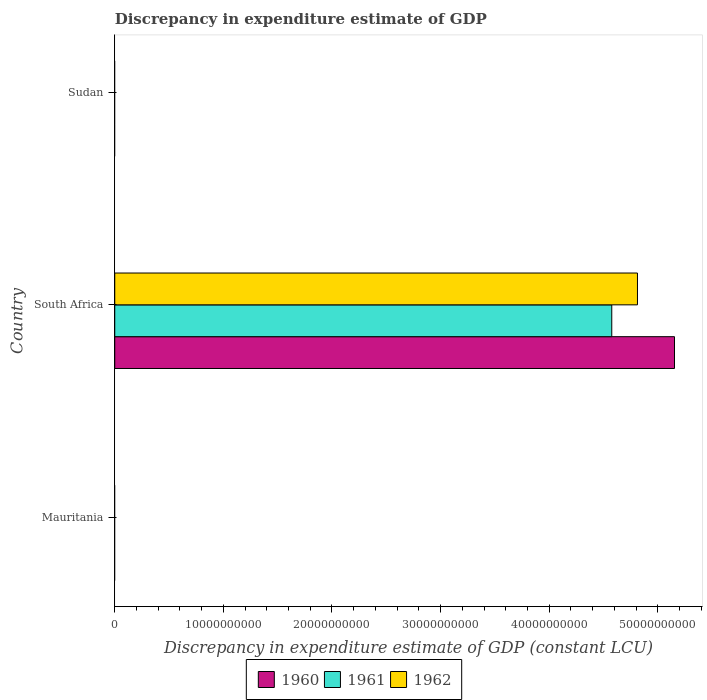How many different coloured bars are there?
Provide a succinct answer. 3. Are the number of bars on each tick of the Y-axis equal?
Your answer should be very brief. No. How many bars are there on the 3rd tick from the top?
Offer a very short reply. 0. How many bars are there on the 3rd tick from the bottom?
Ensure brevity in your answer.  0. What is the label of the 1st group of bars from the top?
Offer a terse response. Sudan. What is the discrepancy in expenditure estimate of GDP in 1960 in South Africa?
Provide a succinct answer. 5.15e+1. Across all countries, what is the maximum discrepancy in expenditure estimate of GDP in 1961?
Your answer should be very brief. 4.58e+1. In which country was the discrepancy in expenditure estimate of GDP in 1961 maximum?
Give a very brief answer. South Africa. What is the total discrepancy in expenditure estimate of GDP in 1961 in the graph?
Your response must be concise. 4.58e+1. What is the difference between the discrepancy in expenditure estimate of GDP in 1961 in Sudan and the discrepancy in expenditure estimate of GDP in 1962 in South Africa?
Make the answer very short. -4.81e+1. What is the average discrepancy in expenditure estimate of GDP in 1960 per country?
Your response must be concise. 1.72e+1. What is the difference between the discrepancy in expenditure estimate of GDP in 1962 and discrepancy in expenditure estimate of GDP in 1961 in South Africa?
Provide a short and direct response. 2.37e+09. In how many countries, is the discrepancy in expenditure estimate of GDP in 1962 greater than 34000000000 LCU?
Offer a terse response. 1. What is the difference between the highest and the lowest discrepancy in expenditure estimate of GDP in 1961?
Your answer should be compact. 4.58e+1. In how many countries, is the discrepancy in expenditure estimate of GDP in 1960 greater than the average discrepancy in expenditure estimate of GDP in 1960 taken over all countries?
Keep it short and to the point. 1. Is it the case that in every country, the sum of the discrepancy in expenditure estimate of GDP in 1961 and discrepancy in expenditure estimate of GDP in 1962 is greater than the discrepancy in expenditure estimate of GDP in 1960?
Ensure brevity in your answer.  No. How many bars are there?
Provide a short and direct response. 3. Does the graph contain any zero values?
Provide a succinct answer. Yes. Does the graph contain grids?
Provide a succinct answer. No. Where does the legend appear in the graph?
Offer a terse response. Bottom center. How many legend labels are there?
Offer a terse response. 3. What is the title of the graph?
Your response must be concise. Discrepancy in expenditure estimate of GDP. Does "1984" appear as one of the legend labels in the graph?
Your answer should be compact. No. What is the label or title of the X-axis?
Your answer should be very brief. Discrepancy in expenditure estimate of GDP (constant LCU). What is the label or title of the Y-axis?
Offer a terse response. Country. What is the Discrepancy in expenditure estimate of GDP (constant LCU) in 1960 in Mauritania?
Your response must be concise. 0. What is the Discrepancy in expenditure estimate of GDP (constant LCU) in 1961 in Mauritania?
Provide a succinct answer. 0. What is the Discrepancy in expenditure estimate of GDP (constant LCU) of 1962 in Mauritania?
Ensure brevity in your answer.  0. What is the Discrepancy in expenditure estimate of GDP (constant LCU) of 1960 in South Africa?
Offer a very short reply. 5.15e+1. What is the Discrepancy in expenditure estimate of GDP (constant LCU) in 1961 in South Africa?
Offer a terse response. 4.58e+1. What is the Discrepancy in expenditure estimate of GDP (constant LCU) in 1962 in South Africa?
Offer a terse response. 4.81e+1. What is the Discrepancy in expenditure estimate of GDP (constant LCU) of 1960 in Sudan?
Your response must be concise. 0. What is the Discrepancy in expenditure estimate of GDP (constant LCU) in 1961 in Sudan?
Provide a short and direct response. 0. What is the Discrepancy in expenditure estimate of GDP (constant LCU) of 1962 in Sudan?
Make the answer very short. 0. Across all countries, what is the maximum Discrepancy in expenditure estimate of GDP (constant LCU) of 1960?
Give a very brief answer. 5.15e+1. Across all countries, what is the maximum Discrepancy in expenditure estimate of GDP (constant LCU) of 1961?
Make the answer very short. 4.58e+1. Across all countries, what is the maximum Discrepancy in expenditure estimate of GDP (constant LCU) in 1962?
Ensure brevity in your answer.  4.81e+1. Across all countries, what is the minimum Discrepancy in expenditure estimate of GDP (constant LCU) of 1960?
Make the answer very short. 0. Across all countries, what is the minimum Discrepancy in expenditure estimate of GDP (constant LCU) of 1961?
Your answer should be very brief. 0. Across all countries, what is the minimum Discrepancy in expenditure estimate of GDP (constant LCU) in 1962?
Your response must be concise. 0. What is the total Discrepancy in expenditure estimate of GDP (constant LCU) of 1960 in the graph?
Offer a very short reply. 5.15e+1. What is the total Discrepancy in expenditure estimate of GDP (constant LCU) of 1961 in the graph?
Give a very brief answer. 4.58e+1. What is the total Discrepancy in expenditure estimate of GDP (constant LCU) of 1962 in the graph?
Provide a short and direct response. 4.81e+1. What is the average Discrepancy in expenditure estimate of GDP (constant LCU) in 1960 per country?
Offer a very short reply. 1.72e+1. What is the average Discrepancy in expenditure estimate of GDP (constant LCU) of 1961 per country?
Your response must be concise. 1.53e+1. What is the average Discrepancy in expenditure estimate of GDP (constant LCU) of 1962 per country?
Make the answer very short. 1.60e+1. What is the difference between the Discrepancy in expenditure estimate of GDP (constant LCU) in 1960 and Discrepancy in expenditure estimate of GDP (constant LCU) in 1961 in South Africa?
Provide a short and direct response. 5.78e+09. What is the difference between the Discrepancy in expenditure estimate of GDP (constant LCU) in 1960 and Discrepancy in expenditure estimate of GDP (constant LCU) in 1962 in South Africa?
Ensure brevity in your answer.  3.41e+09. What is the difference between the Discrepancy in expenditure estimate of GDP (constant LCU) of 1961 and Discrepancy in expenditure estimate of GDP (constant LCU) of 1962 in South Africa?
Keep it short and to the point. -2.37e+09. What is the difference between the highest and the lowest Discrepancy in expenditure estimate of GDP (constant LCU) of 1960?
Ensure brevity in your answer.  5.15e+1. What is the difference between the highest and the lowest Discrepancy in expenditure estimate of GDP (constant LCU) of 1961?
Give a very brief answer. 4.58e+1. What is the difference between the highest and the lowest Discrepancy in expenditure estimate of GDP (constant LCU) of 1962?
Offer a terse response. 4.81e+1. 